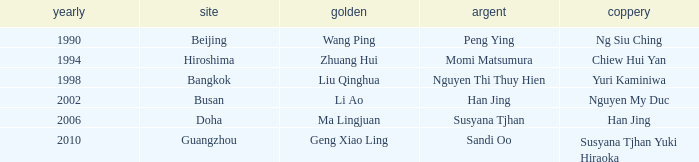What Silver has a Golf of Li AO? Han Jing. 